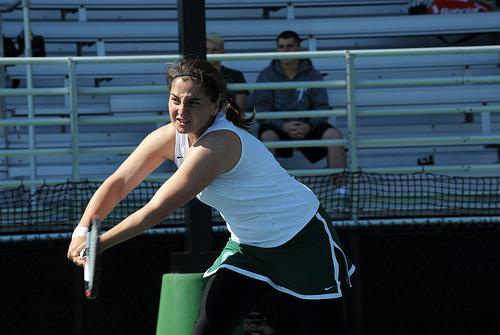Question: what is she holding?
Choices:
A. A bat.
B. A ball.
C. A hat.
D. A racket.
Answer with the letter. Answer: D Question: what game is she playing?
Choices:
A. Chess.
B. Basketball.
C. Tennis.
D. Softball.
Answer with the letter. Answer: C Question: what is the girl doing?
Choices:
A. Running.
B. Playing.
C. Walking.
D. Sleeping.
Answer with the letter. Answer: B Question: why is she running?
Choices:
A. To race.
B. To hit the ball.
C. To catch a ball.
D. To catch up to someone.
Answer with the letter. Answer: B Question: who is she with?
Choices:
A. A man.
B. No one.
C. A woman.
D. A child.
Answer with the letter. Answer: B 